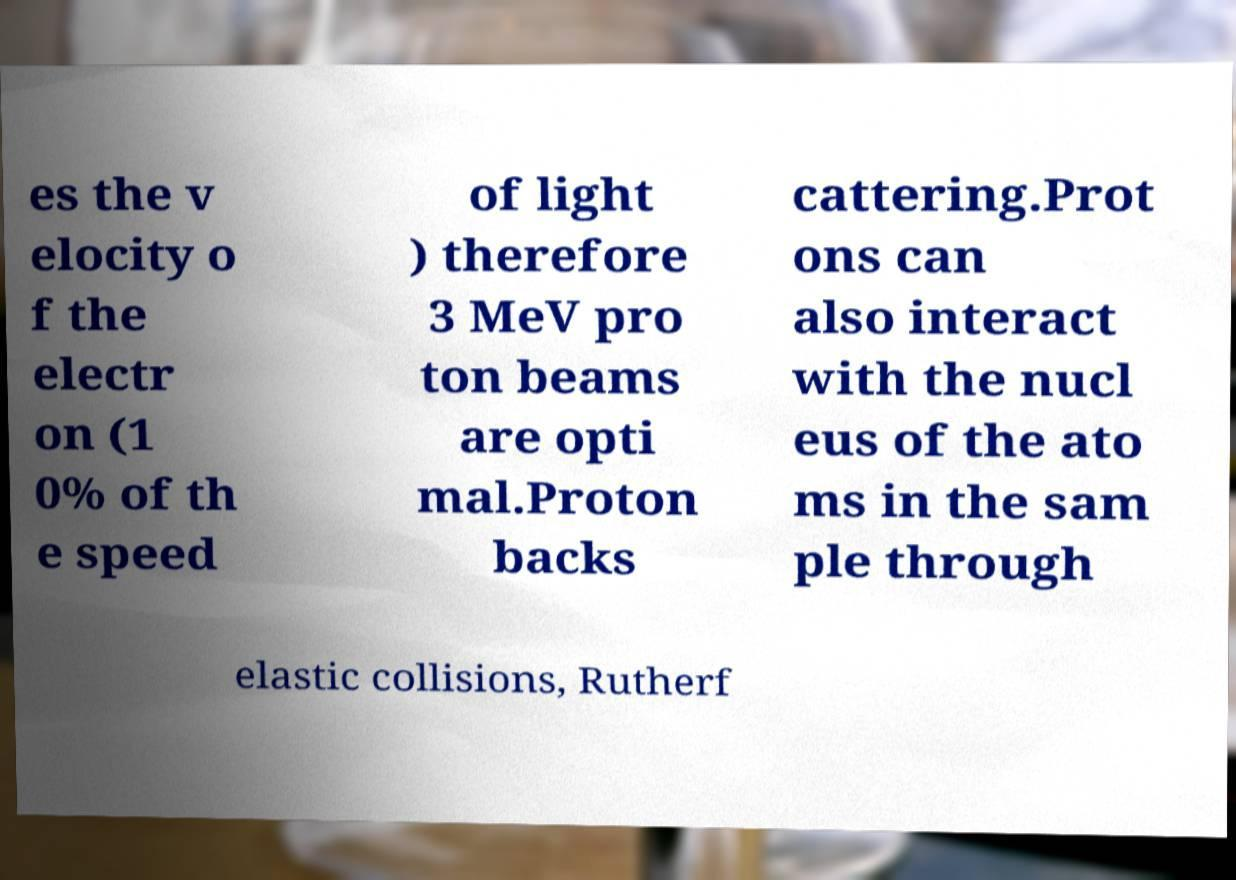There's text embedded in this image that I need extracted. Can you transcribe it verbatim? es the v elocity o f the electr on (1 0% of th e speed of light ) therefore 3 MeV pro ton beams are opti mal.Proton backs cattering.Prot ons can also interact with the nucl eus of the ato ms in the sam ple through elastic collisions, Rutherf 